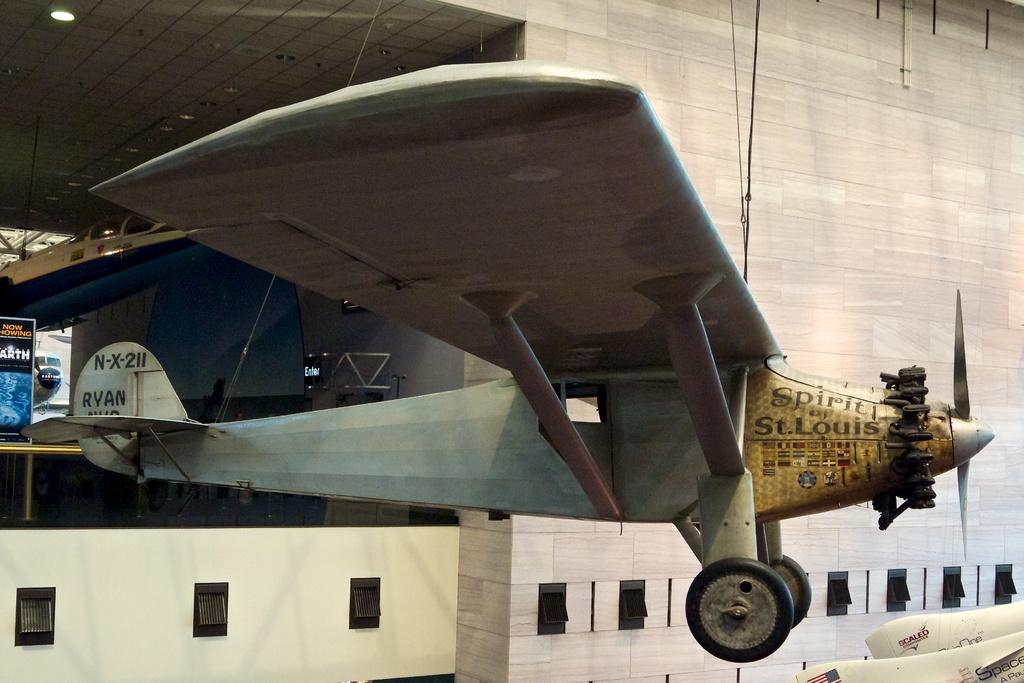Provide a one-sentence caption for the provided image. An airplane displays "Spirit of St. Louis" on the right side of the nose. 